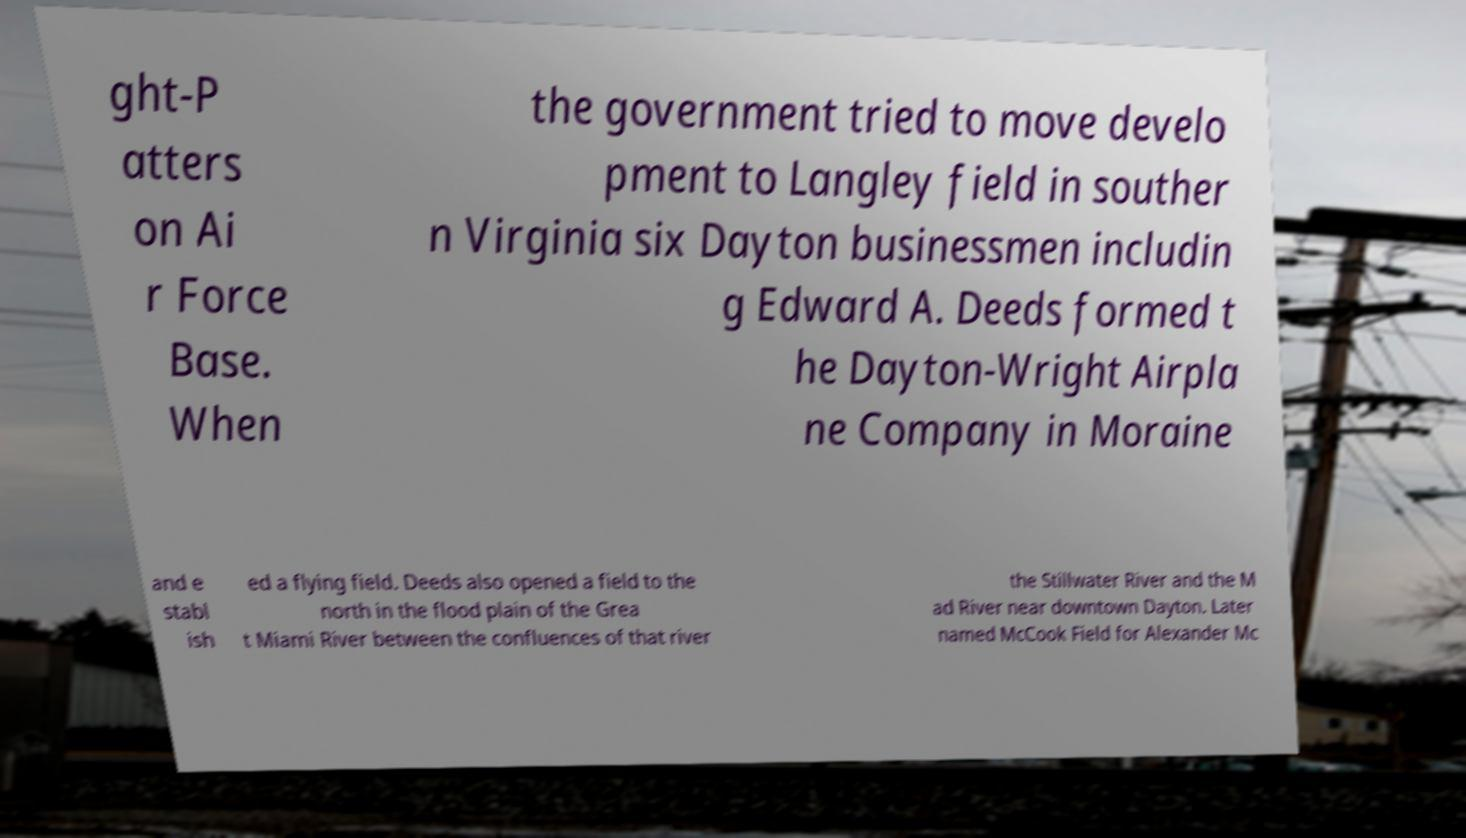There's text embedded in this image that I need extracted. Can you transcribe it verbatim? ght-P atters on Ai r Force Base. When the government tried to move develo pment to Langley field in souther n Virginia six Dayton businessmen includin g Edward A. Deeds formed t he Dayton-Wright Airpla ne Company in Moraine and e stabl ish ed a flying field. Deeds also opened a field to the north in the flood plain of the Grea t Miami River between the confluences of that river the Stillwater River and the M ad River near downtown Dayton. Later named McCook Field for Alexander Mc 